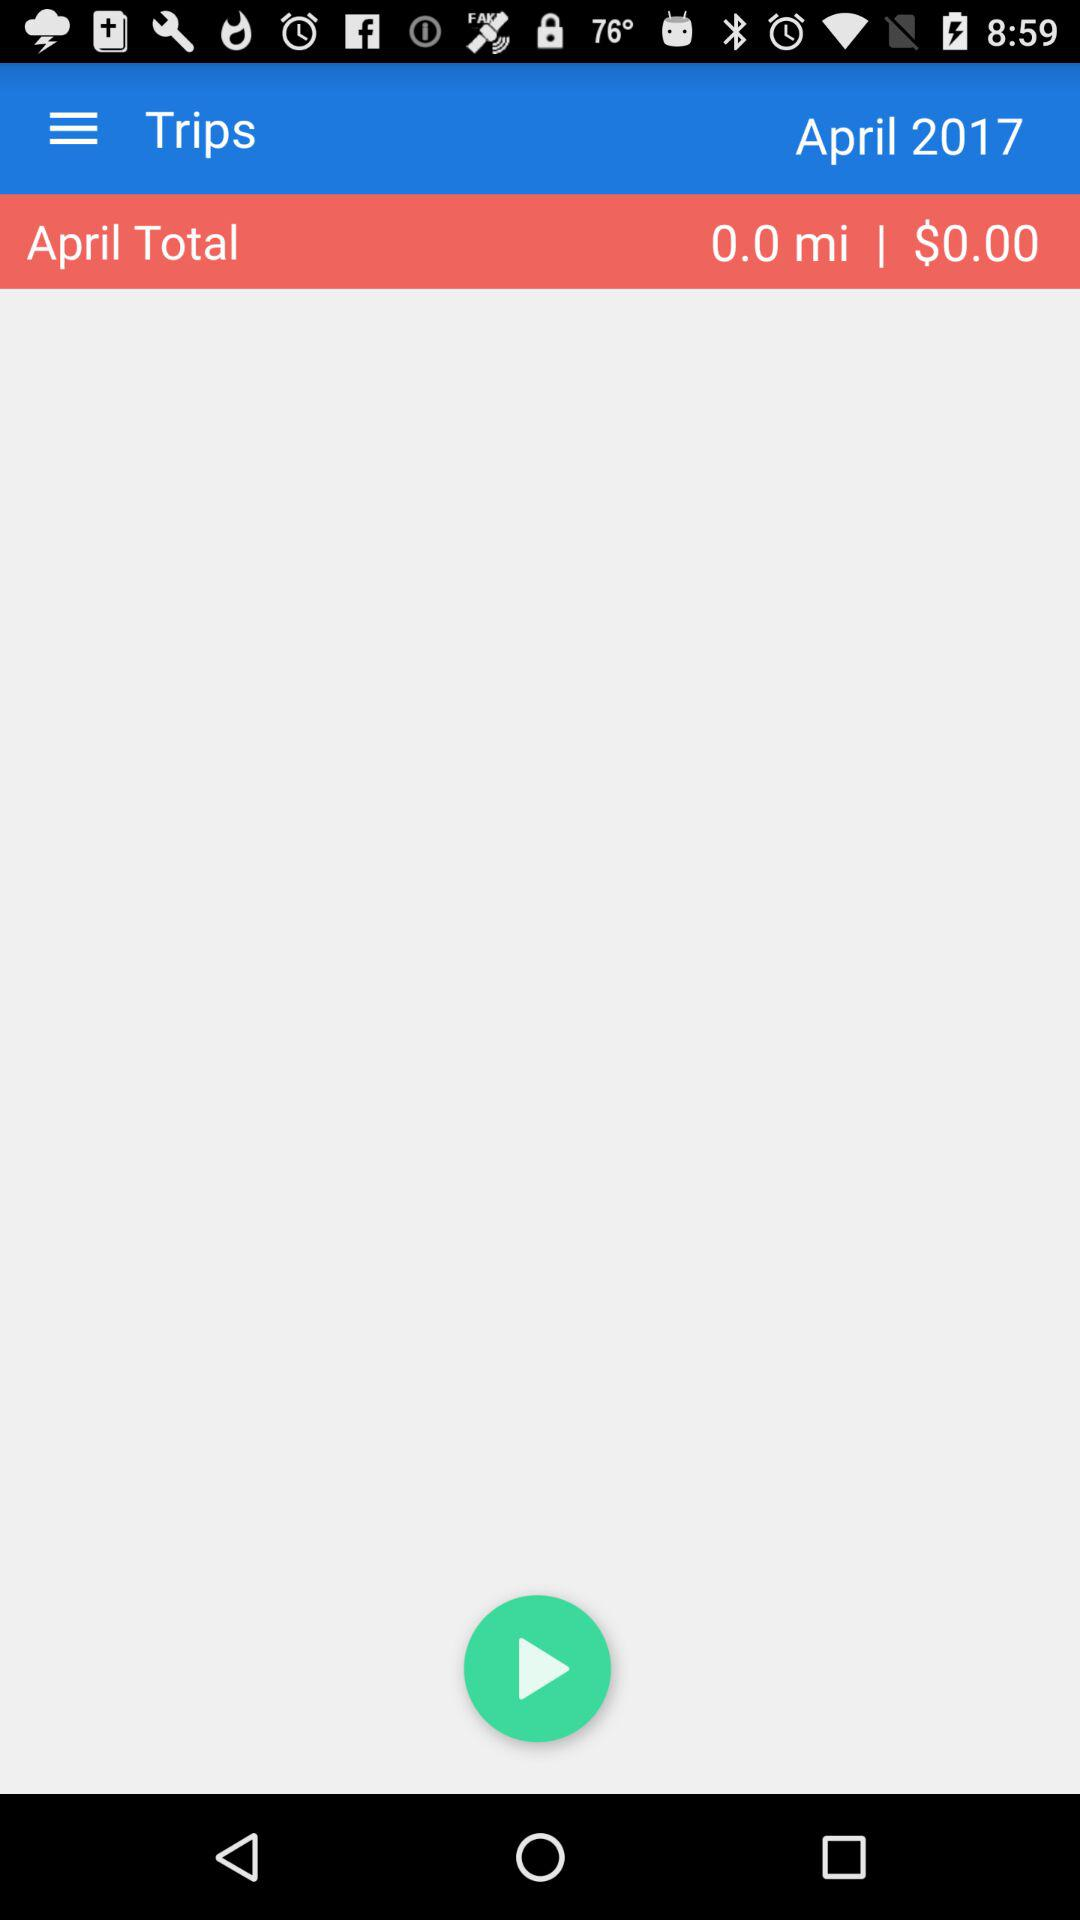What is the April total? The April total is 0.00 miles and $0.00. 